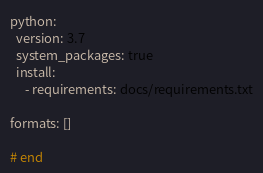Convert code to text. <code><loc_0><loc_0><loc_500><loc_500><_YAML_>python:
  version: 3.7
  system_packages: true 
  install:
     - requirements: docs/requirements.txt

formats: []

# end
</code> 